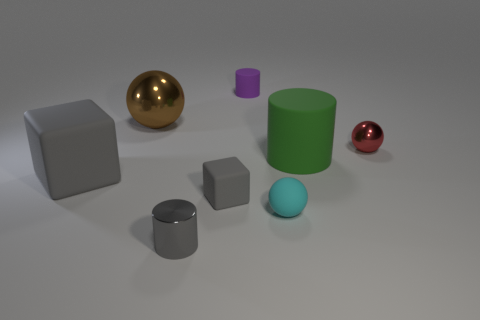Subtract all red spheres. Subtract all brown blocks. How many spheres are left? 2 Add 1 tiny shiny objects. How many objects exist? 9 Subtract all balls. How many objects are left? 5 Subtract 0 blue balls. How many objects are left? 8 Subtract all metal objects. Subtract all gray shiny cylinders. How many objects are left? 4 Add 2 small red spheres. How many small red spheres are left? 3 Add 7 tiny yellow cubes. How many tiny yellow cubes exist? 7 